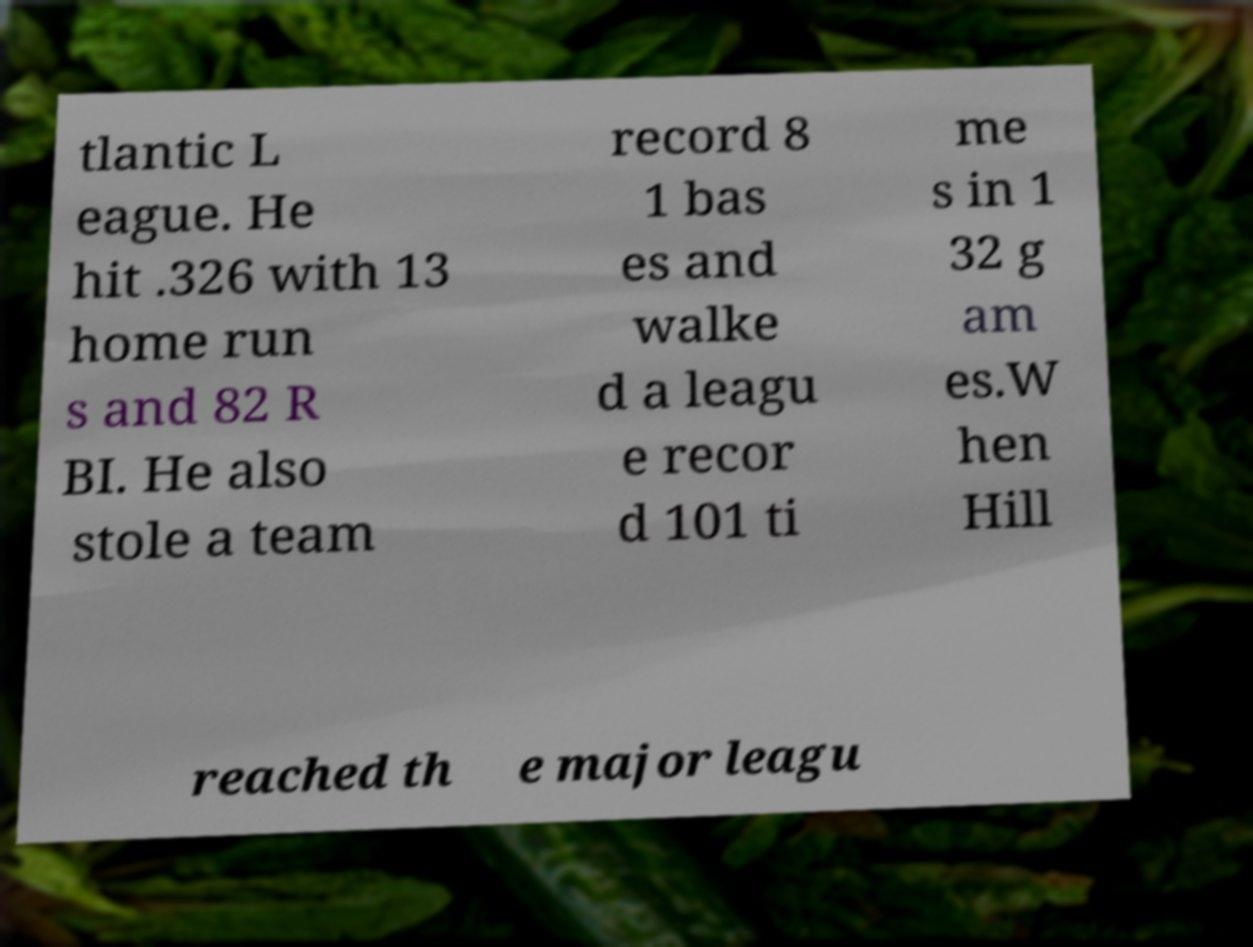Can you accurately transcribe the text from the provided image for me? tlantic L eague. He hit .326 with 13 home run s and 82 R BI. He also stole a team record 8 1 bas es and walke d a leagu e recor d 101 ti me s in 1 32 g am es.W hen Hill reached th e major leagu 